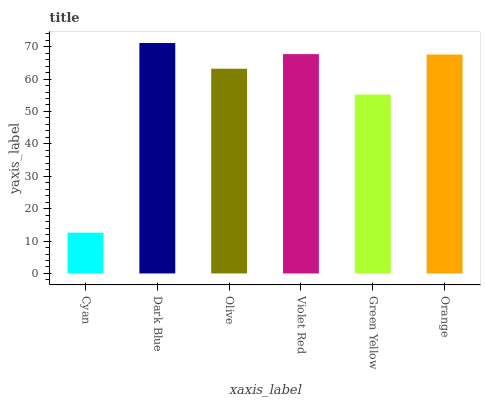Is Cyan the minimum?
Answer yes or no. Yes. Is Dark Blue the maximum?
Answer yes or no. Yes. Is Olive the minimum?
Answer yes or no. No. Is Olive the maximum?
Answer yes or no. No. Is Dark Blue greater than Olive?
Answer yes or no. Yes. Is Olive less than Dark Blue?
Answer yes or no. Yes. Is Olive greater than Dark Blue?
Answer yes or no. No. Is Dark Blue less than Olive?
Answer yes or no. No. Is Orange the high median?
Answer yes or no. Yes. Is Olive the low median?
Answer yes or no. Yes. Is Violet Red the high median?
Answer yes or no. No. Is Dark Blue the low median?
Answer yes or no. No. 